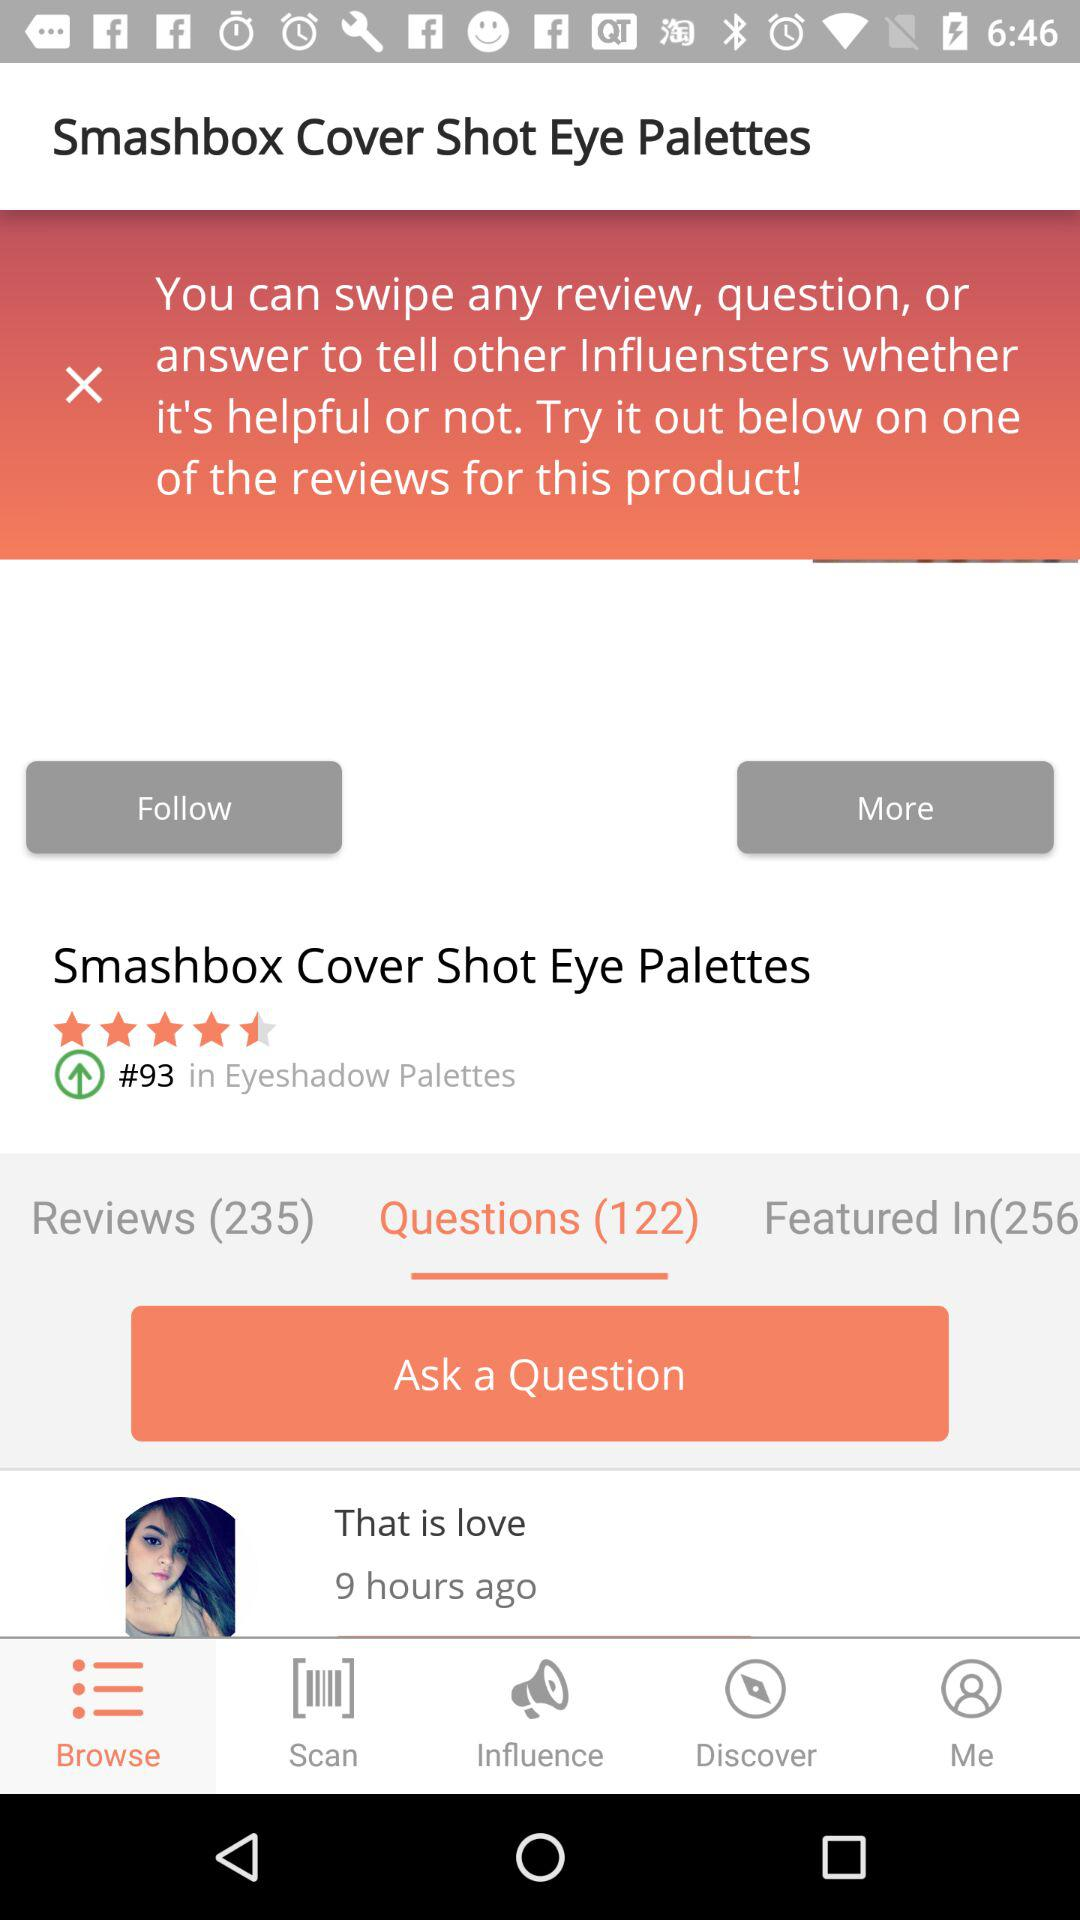How many reviews does this product have?
Answer the question using a single word or phrase. 235 